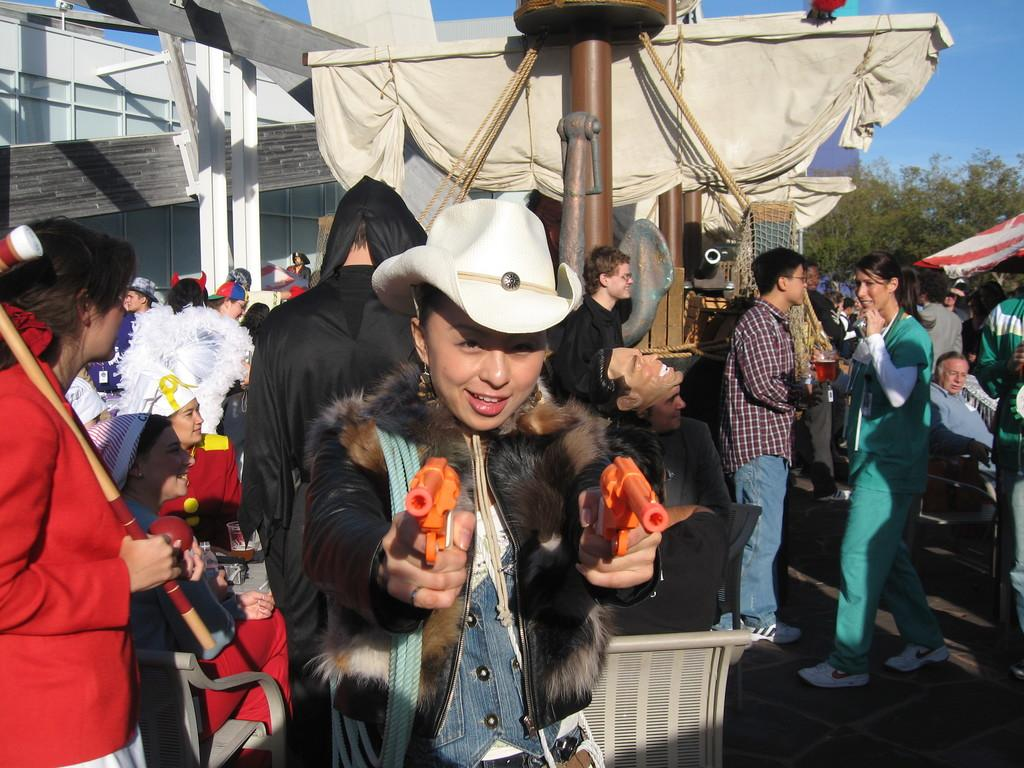Who is the main subject in the image? There is a woman in the image. What is the woman holding in the image? The woman is holding guns. What can be seen in the background of the image? There is a group of people, at least one building, clothes, trees, and the sky visible in the background of the image. What type of balance does the woman have while holding the guns in the image? The image does not provide information about the woman's balance while holding the guns. Can you see any roses in the image? There are no roses present in the image. 